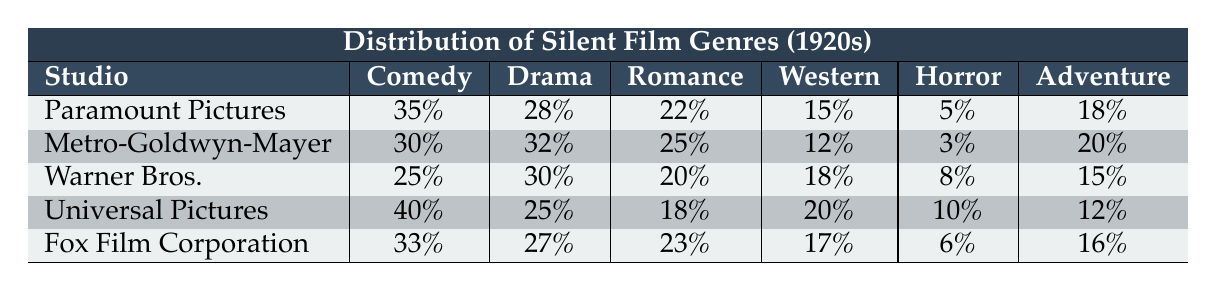What studio produced the highest percentage of comedy films? Looking at the 'Comedy' column, Paramount Pictures has the highest value at 35%.
Answer: Paramount Pictures What is the percentage of horror films produced by Metro-Goldwyn-Mayer? In the 'Horror' column for Metro-Goldwyn-Mayer, the percentage is 3%.
Answer: 3% Which studio produced the largest percentage of drama films? The 'Drama' column shows that Metro-Goldwyn-Mayer has the highest value at 32%.
Answer: Metro-Goldwyn-Mayer What is the combined percentage of romance and adventure films produced by Warner Bros.? In the 'Romance' column, Warner Bros. has 20% and in the 'Adventure' column, it has 15%. The sum is 20% + 15% = 35%.
Answer: 35% Does Fox Film Corporation produce more adventure films than horror films? Fox Film Corporation has 16% in 'Adventure' and 6% in 'Horror', meaning it produces more adventure films (16% > 6%).
Answer: Yes What is the average percentage of western films across all studios? The percentages for 'Western' are 15, 12, 18, 20, and 17. The average is (15 + 12 + 18 + 20 + 17)/5 = 16.4%.
Answer: 16.4% Which studio has the lowest percentage for romance films? In the 'Romance' column, Universal Pictures has the lowest percentage at 18%.
Answer: Universal Pictures Calculate the difference in percentage between the studio with the most comedy films and the studio with the least. Paramount Pictures has 35% and Metro-Goldwyn-Mayer has 30% for comedy. The difference is 35% - 30% = 5%.
Answer: 5% What is the total percentage of films produced by Universal Pictures across all genres? The total percentages for Universal Pictures are 40 + 25 + 18 + 20 + 10 + 12 = 135%.
Answer: 135% Which genre was least produced by Paramount Pictures? In the 'Horror' category, Paramount Pictures has the lowest percentage at 5%.
Answer: Horror 